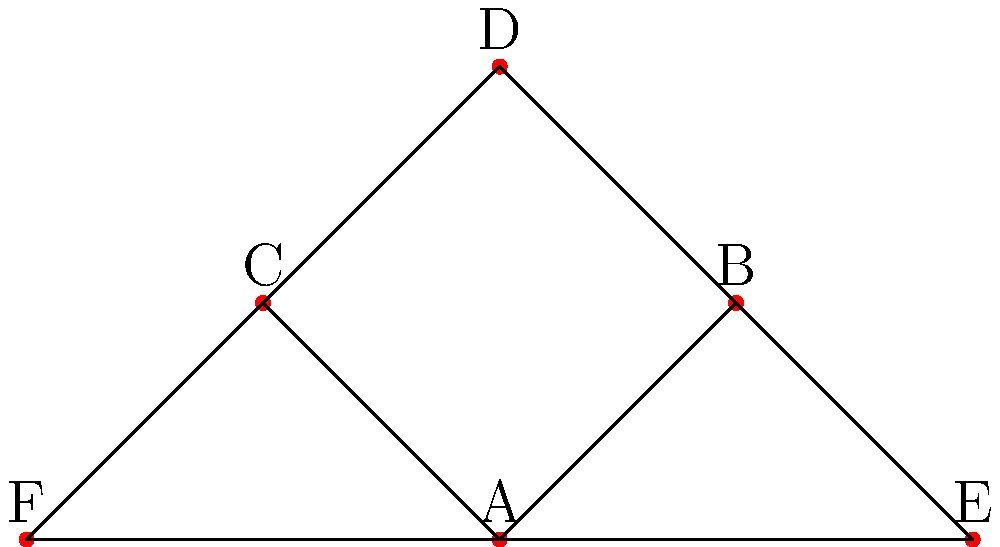In this simplified circulatory system diagram, blood vessels are represented as edges connecting various points (A, B, C, D, E, F). If we consider the group of symmetries of this diagram, what is the order of the symmetry group? To determine the order of the symmetry group, let's follow these steps:

1) First, observe the structure of the diagram:
   - There's a central point A connected to all other points.
   - Points B, C, D form a triangle around A.
   - Points E and F are symmetrically placed on either side.

2) The symmetries we can identify are:
   - Identity (do nothing)
   - Reflection across the vertical axis through A and D
   - 120° rotation clockwise around A (B → C → E → B)
   - 120° rotation counterclockwise around A (B → E → C → B)

3) Let's verify these are all the symmetries:
   - The reflection swaps B with C and E with F
   - The rotations cycle B, C, and E while swapping D with either E or F

4) We can confirm there are no other symmetries because:
   - Any other rotation would disrupt the structure
   - Any other reflection axis would not preserve the connections

5) Count the number of symmetries:
   - 1 (identity) + 1 (reflection) + 2 (rotations) = 4

Therefore, the symmetry group has 4 elements, so its order is 4.
Answer: 4 